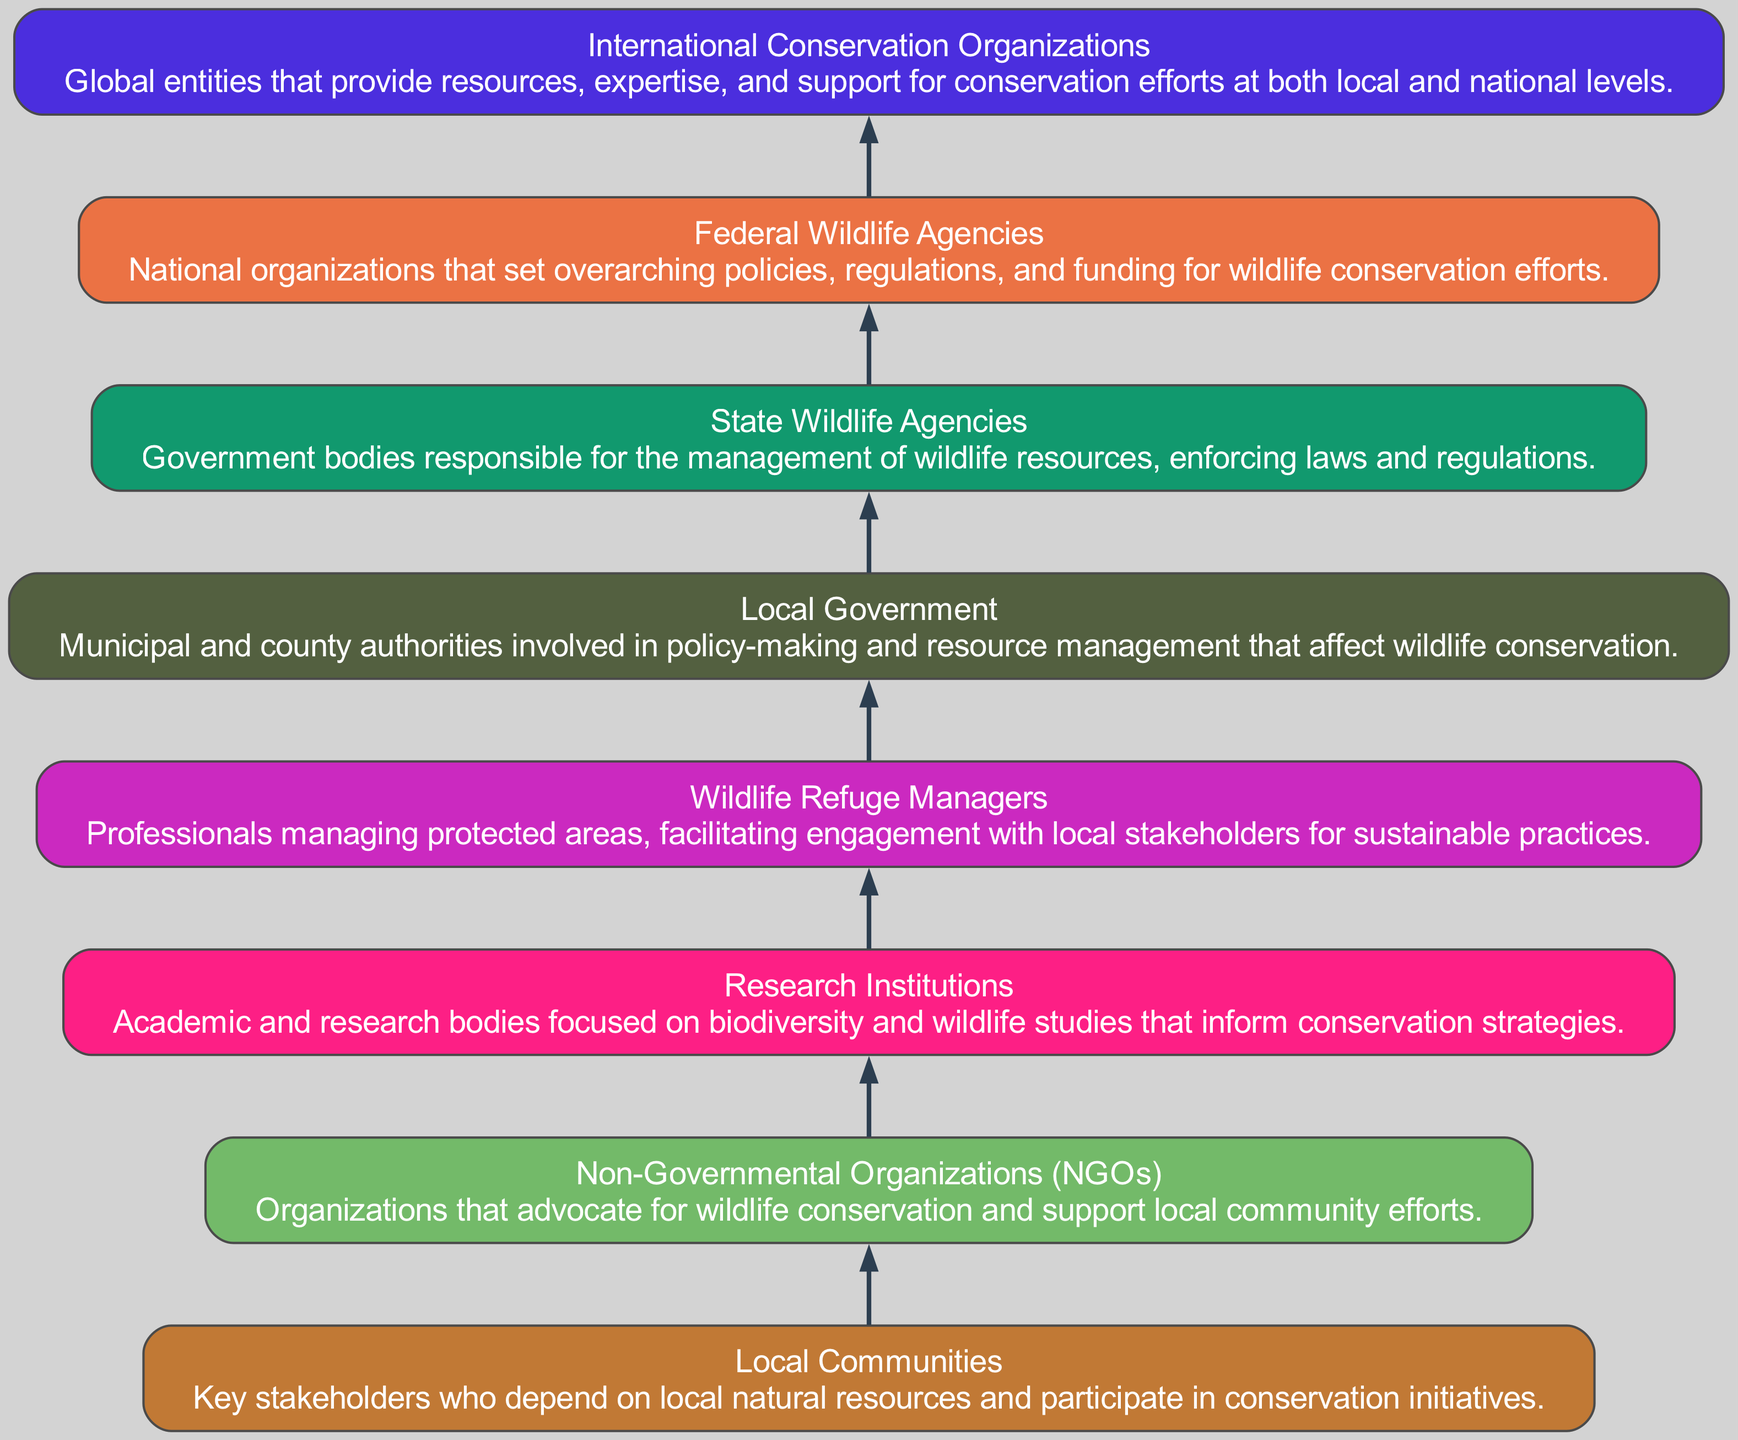What is the topmost node in the diagram? The topmost node in the diagram is the "International Conservation Organizations," which is the final stakeholder in the flow representation.
Answer: International Conservation Organizations How many total stakeholders are represented in the diagram? The diagram contains eight distinct stakeholders involved in wildlife conservation, beginning with local communities and ending with international organizations.
Answer: Eight What role do Local Communities play in the diagram? Local Communities are depicted as the foundational stakeholders who depend on natural resources and engage actively in conservation strategies, making them essential for the success of the initiatives.
Answer: Key stakeholders Which stakeholder is shown immediately above Wildlife Refuge Managers? The stakeholder directly above "Wildlife Refuge Managers" is "Research Institutions," indicating that research informs the management of wildlife refuges.
Answer: Research Institutions What is the relationship between NGOs and Local Governments? NGOs and Local Governments both play significant roles in supporting conservation efforts; however, the flow indicates that NGOs are positioned to advocate and support policies that involve Local Governments.
Answer: Advocacy and support How do Federal Wildlife Agencies relate in terms of influence? Federal Wildlife Agencies have the highest level of influence in the structure and are responsible for establishing overarching policies and funding, indicating their role  influences all stakeholders below them in the flow.
Answer: Highest level of influence Which stakeholder has a direct link with both Local Government and State Wildlife Agencies? The "Wildlife Refuge Managers" stakeholder has a direct link connecting both Local Government and State Wildlife Agencies, signifying their role at the interface of local policy and state management.
Answer: Wildlife Refuge Managers What is the main function of State Wildlife Agencies in the chart? State Wildlife Agencies are responsible for managing wildlife resources, enforcing laws and regulations, which is critical for aligning local and state conservation efforts.
Answer: Management of wildlife resources What characteristic is unique to the nodes in this Bottom Up Flow Chart? The characteristic unique to this diagram is that each node represents stakeholders in a hierarchical structure, emphasizing the flow of influence and engagement from local stakeholders to international organizations.
Answer: Hierarchical structure What flow direction does this Bottom Up Flow Chart represent? The diagram illustrates a bottom-up flow direction, indicating the influence and engagement begins from the Local Communities at the bottom and moves upward towards Federal Wildlife Agencies at the top.
Answer: Bottom-up flow 